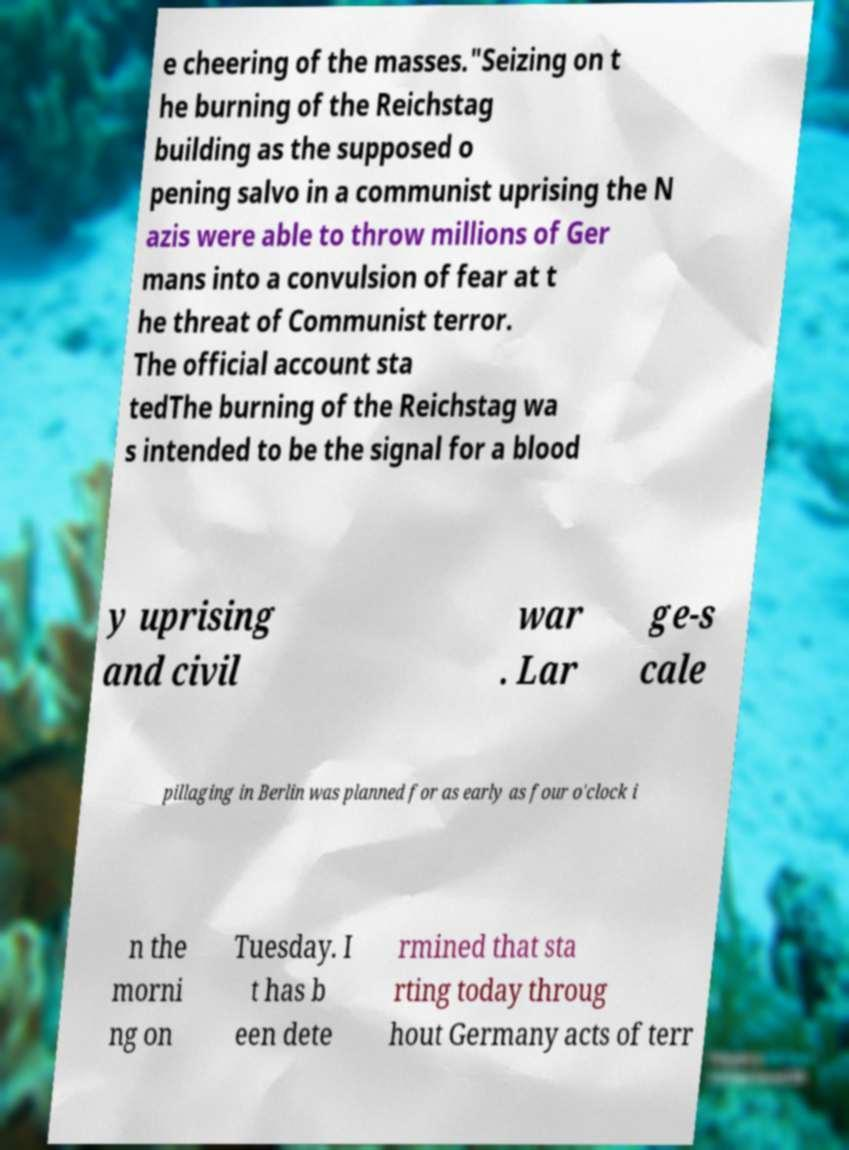For documentation purposes, I need the text within this image transcribed. Could you provide that? e cheering of the masses."Seizing on t he burning of the Reichstag building as the supposed o pening salvo in a communist uprising the N azis were able to throw millions of Ger mans into a convulsion of fear at t he threat of Communist terror. The official account sta tedThe burning of the Reichstag wa s intended to be the signal for a blood y uprising and civil war . Lar ge-s cale pillaging in Berlin was planned for as early as four o'clock i n the morni ng on Tuesday. I t has b een dete rmined that sta rting today throug hout Germany acts of terr 